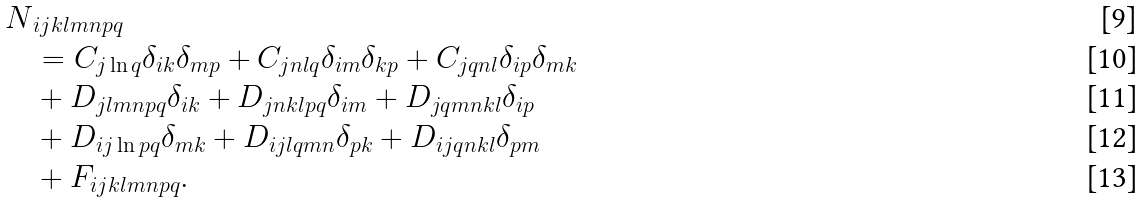<formula> <loc_0><loc_0><loc_500><loc_500>N & _ { i j k l m n p q } \\ & = C _ { j \ln q } \delta _ { i k } \delta _ { m p } + C _ { j n l q } \delta _ { i m } \delta _ { k p } + C _ { j q n l } \delta _ { i p } \delta _ { m k } \\ & + D _ { j l m n p q } \delta _ { i k } + D _ { j n k l p q } \delta _ { i m } + D _ { j q m n k l } \delta _ { i p } \\ & + D _ { i j \ln p q } \delta _ { m k } + D _ { i j l q m n } \delta _ { p k } + D _ { i j q n k l } \delta _ { p m } \\ & + F _ { i j k l m n p q } .</formula> 